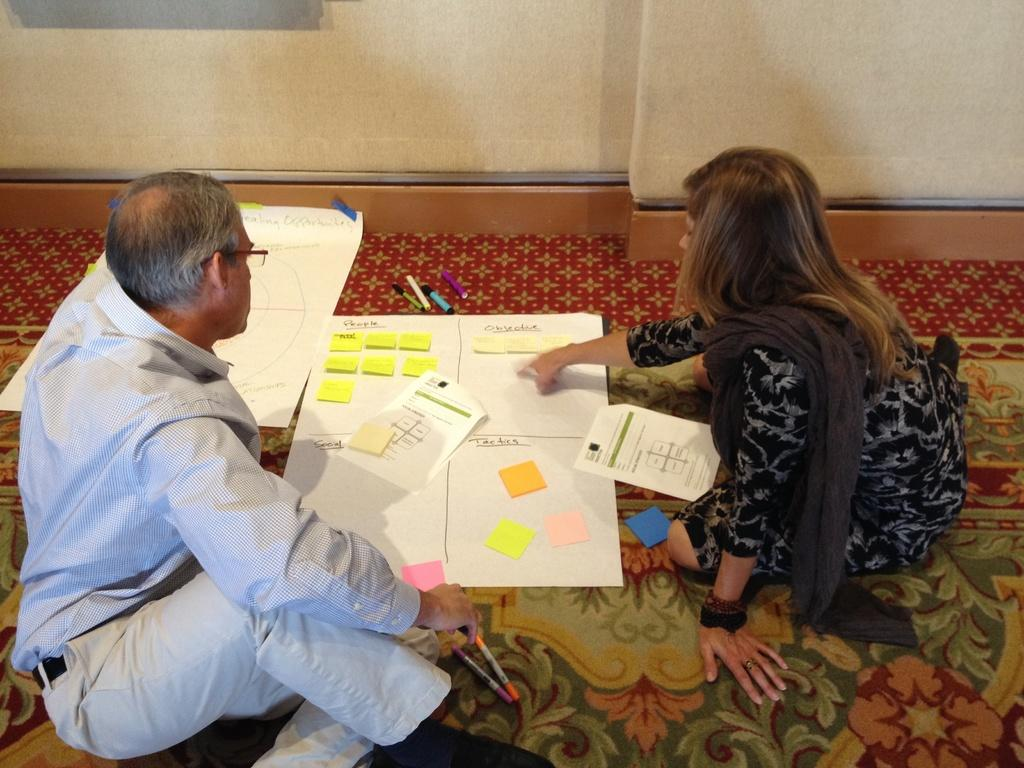How many people are present in the image? There are two people in the image. What are the people sitting on? The people are sitting on a carpet. What type of visual aids can be seen in the image? There are charts, sketches, and papers in the image. What color is the feather that is being used to draw on the crayon in the image? There is no feather or crayon present in the image; it only features two people sitting on a carpet with charts, sketches, and papers. 